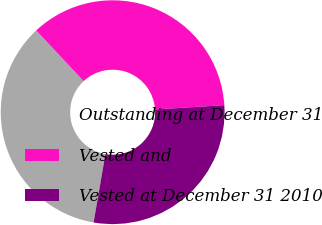<chart> <loc_0><loc_0><loc_500><loc_500><pie_chart><fcel>Outstanding at December 31<fcel>Vested and<fcel>Vested at December 31 2010<nl><fcel>35.31%<fcel>35.97%<fcel>28.73%<nl></chart> 